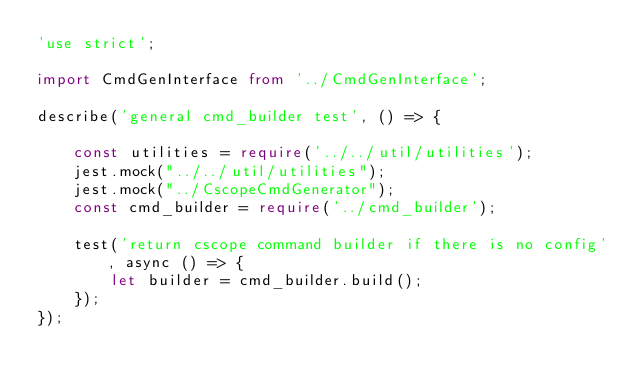<code> <loc_0><loc_0><loc_500><loc_500><_TypeScript_>'use strict';

import CmdGenInterface from '../CmdGenInterface';

describe('general cmd_builder test', () => {

    const utilities = require('../../util/utilities');
    jest.mock("../../util/utilities");
    jest.mock("../CscopeCmdGenerator");
    const cmd_builder = require('../cmd_builder');

    test('return cscope command builder if there is no config', async () => {
        let builder = cmd_builder.build();
    });
});</code> 